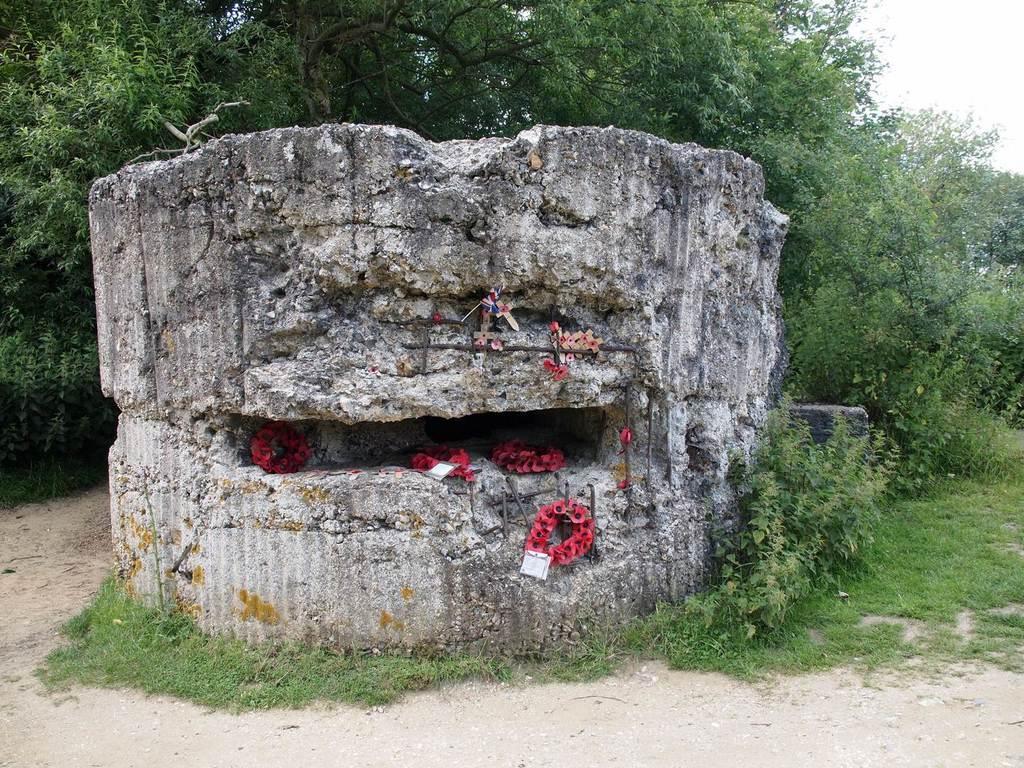Can you describe this image briefly? In this image I can see a big rock in the middle with some objects, around that we can see some grass, plants, road and trees. 